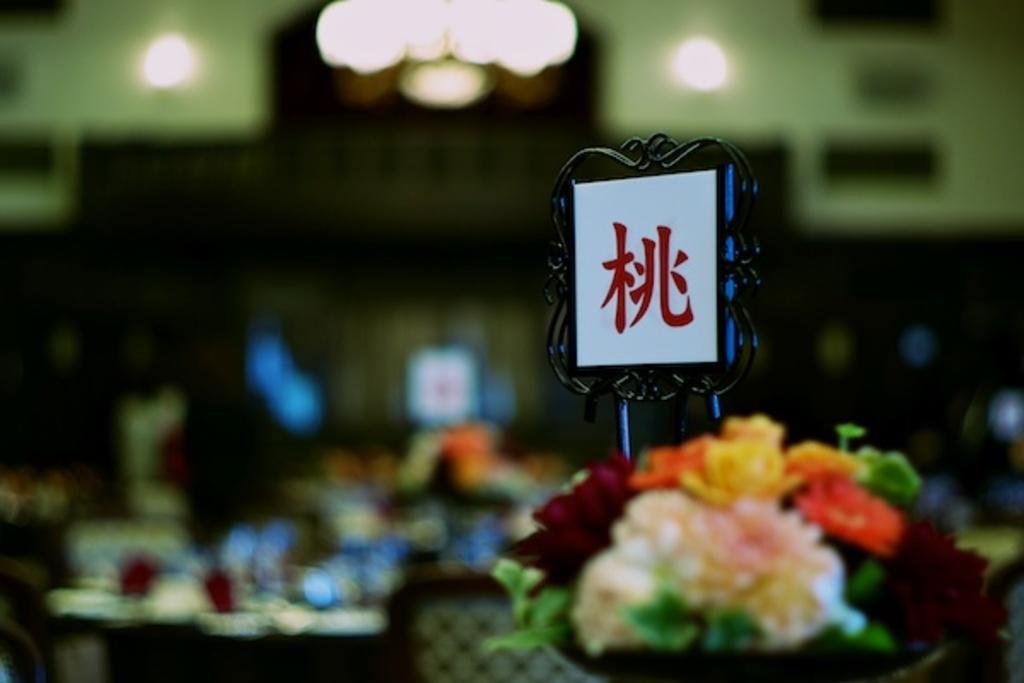Can you describe this image briefly? Here in this picture we can see a flower bouquet present over there and on that we can see a name board present and we can also see lights present in a blurry manner and we can see other things on the table which are in blurry manner over there. 